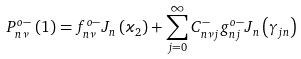Convert formula to latex. <formula><loc_0><loc_0><loc_500><loc_500>P _ { n \nu } ^ { o - } \left ( 1 \right ) = f _ { n \nu } ^ { o - } J _ { n } \left ( \varkappa _ { 2 } \right ) + \sum _ { j = 0 } ^ { \infty } C _ { n \nu j } ^ { - } g _ { n j } ^ { o - } J _ { n } \left ( \gamma _ { j n } \right )</formula> 